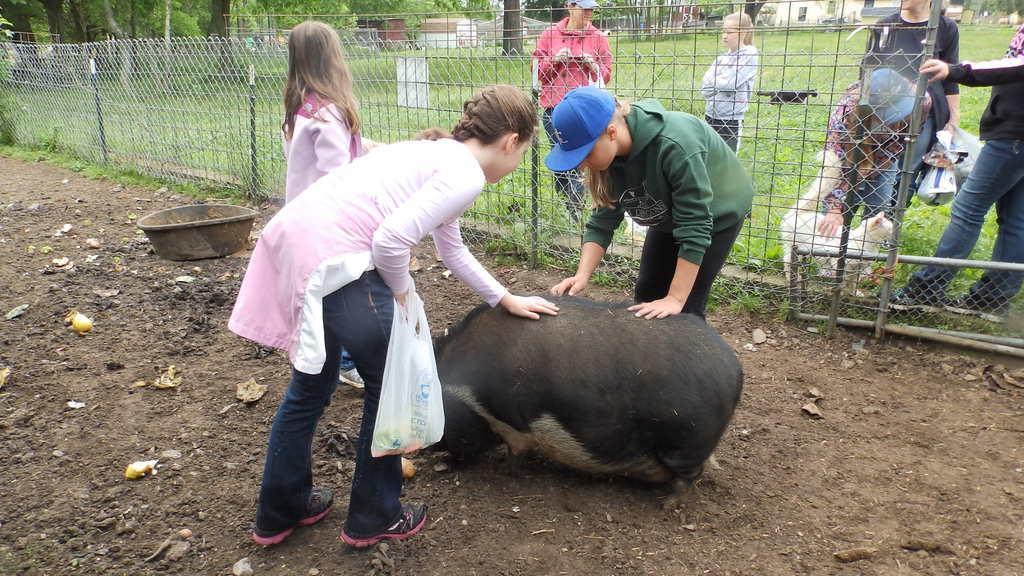Describe this image in one or two sentences. In this image we can see some animals on the ground, we can also see a group of people standing, some people are holding bags in their hand. In the center of the image we can see a fence, poles. At the top of the image we can see a group of trees and buildings. 